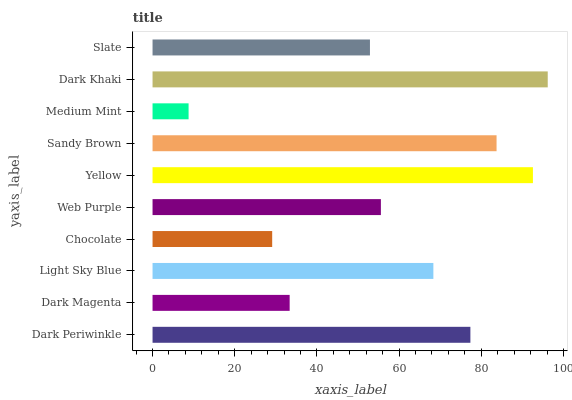Is Medium Mint the minimum?
Answer yes or no. Yes. Is Dark Khaki the maximum?
Answer yes or no. Yes. Is Dark Magenta the minimum?
Answer yes or no. No. Is Dark Magenta the maximum?
Answer yes or no. No. Is Dark Periwinkle greater than Dark Magenta?
Answer yes or no. Yes. Is Dark Magenta less than Dark Periwinkle?
Answer yes or no. Yes. Is Dark Magenta greater than Dark Periwinkle?
Answer yes or no. No. Is Dark Periwinkle less than Dark Magenta?
Answer yes or no. No. Is Light Sky Blue the high median?
Answer yes or no. Yes. Is Web Purple the low median?
Answer yes or no. Yes. Is Chocolate the high median?
Answer yes or no. No. Is Light Sky Blue the low median?
Answer yes or no. No. 